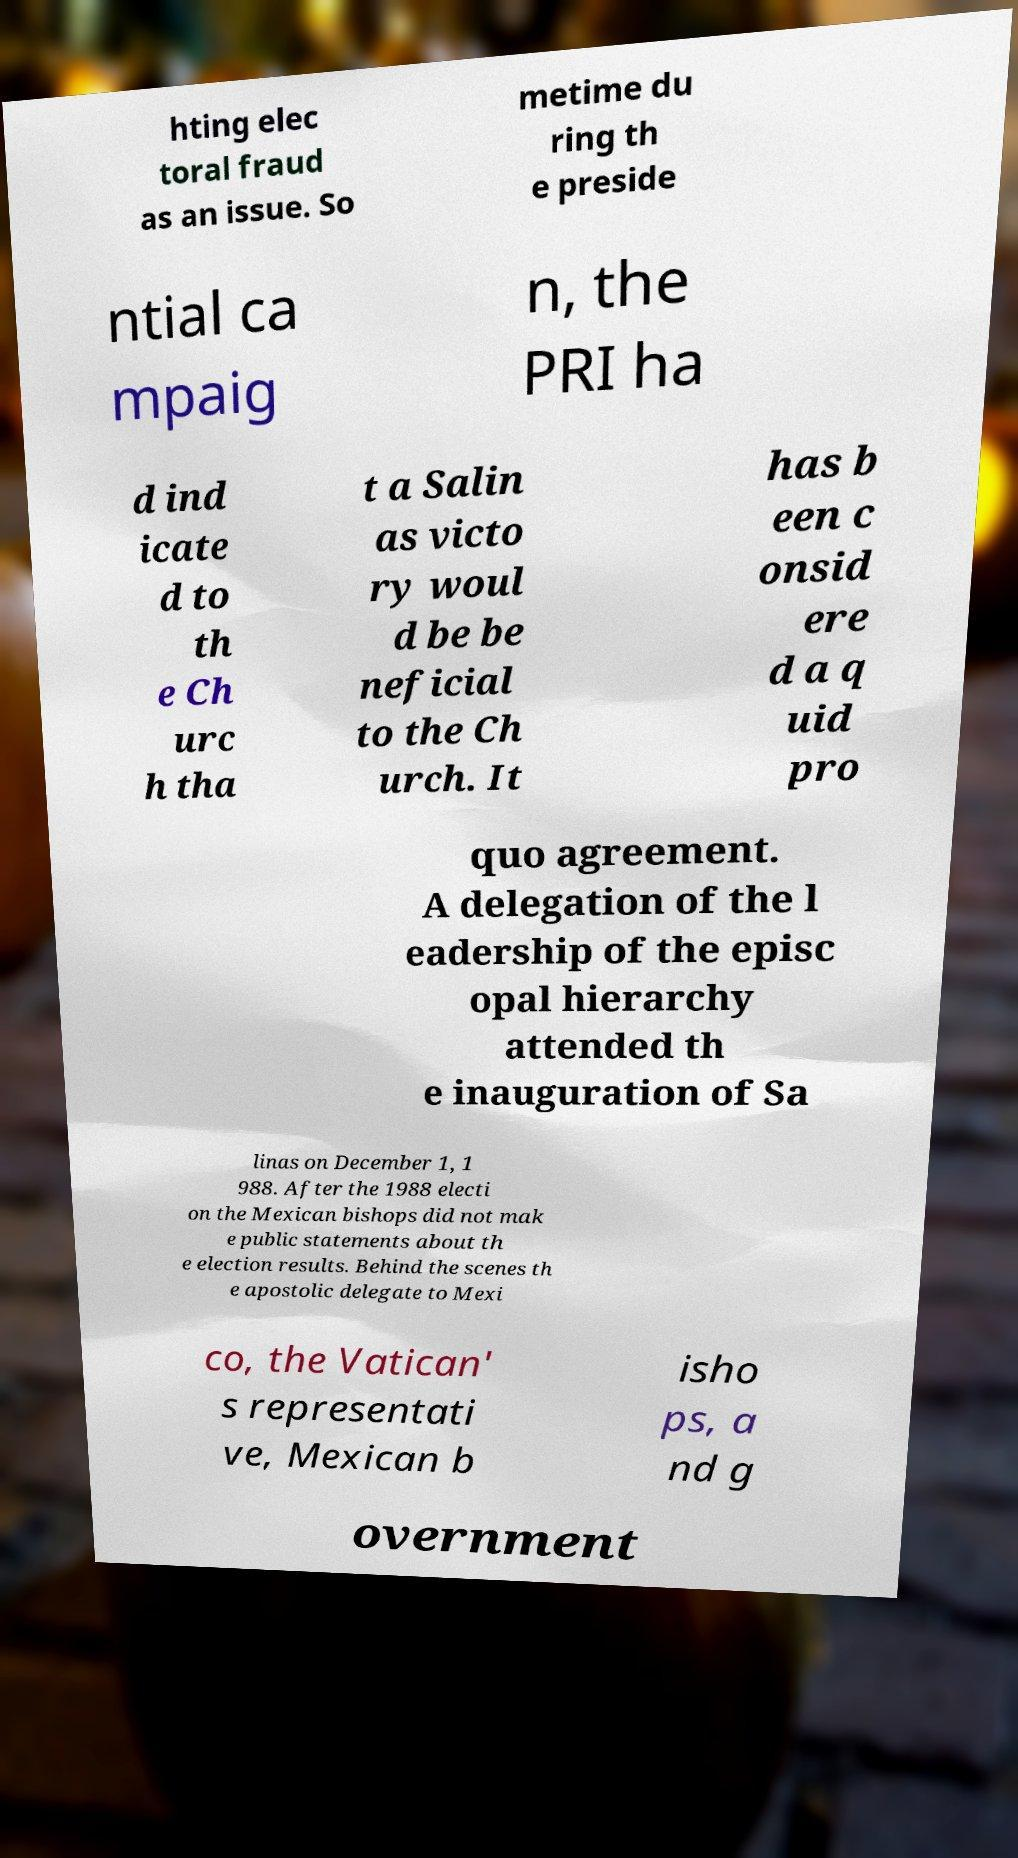Please identify and transcribe the text found in this image. hting elec toral fraud as an issue. So metime du ring th e preside ntial ca mpaig n, the PRI ha d ind icate d to th e Ch urc h tha t a Salin as victo ry woul d be be neficial to the Ch urch. It has b een c onsid ere d a q uid pro quo agreement. A delegation of the l eadership of the episc opal hierarchy attended th e inauguration of Sa linas on December 1, 1 988. After the 1988 electi on the Mexican bishops did not mak e public statements about th e election results. Behind the scenes th e apostolic delegate to Mexi co, the Vatican' s representati ve, Mexican b isho ps, a nd g overnment 